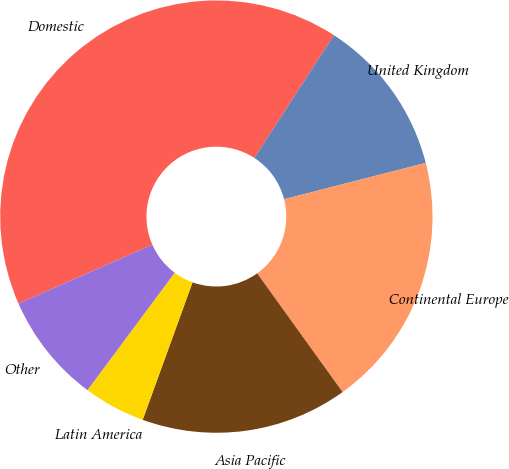Convert chart. <chart><loc_0><loc_0><loc_500><loc_500><pie_chart><fcel>Domestic<fcel>United Kingdom<fcel>Continental Europe<fcel>Asia Pacific<fcel>Latin America<fcel>Other<nl><fcel>40.74%<fcel>11.85%<fcel>19.07%<fcel>15.46%<fcel>4.63%<fcel>8.24%<nl></chart> 